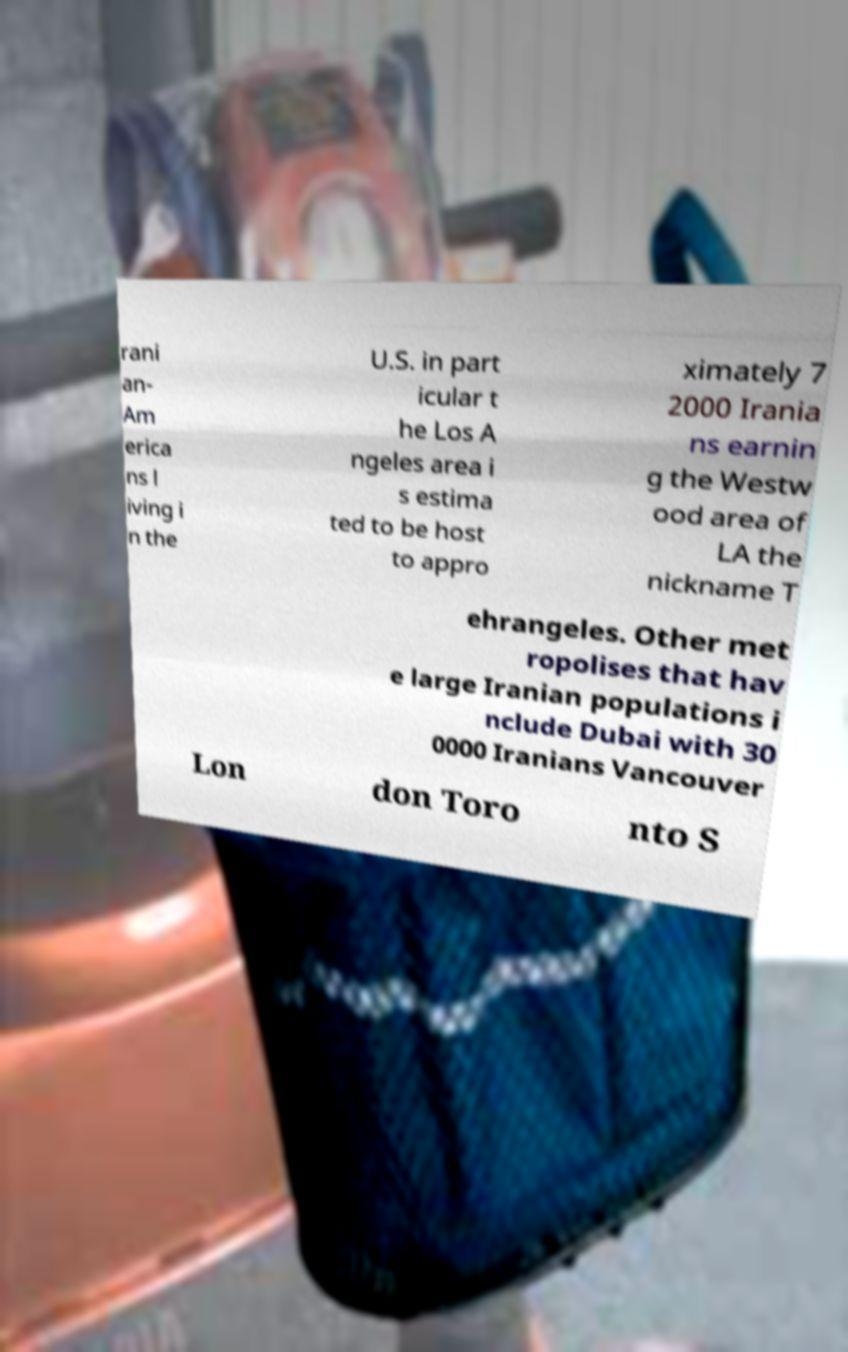Could you assist in decoding the text presented in this image and type it out clearly? rani an- Am erica ns l iving i n the U.S. in part icular t he Los A ngeles area i s estima ted to be host to appro ximately 7 2000 Irania ns earnin g the Westw ood area of LA the nickname T ehrangeles. Other met ropolises that hav e large Iranian populations i nclude Dubai with 30 0000 Iranians Vancouver Lon don Toro nto S 